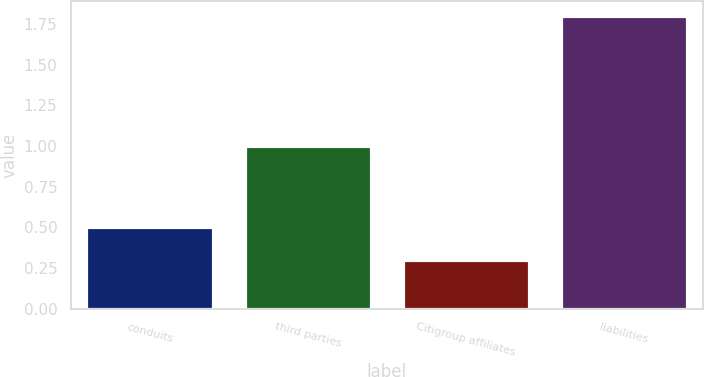Convert chart. <chart><loc_0><loc_0><loc_500><loc_500><bar_chart><fcel>conduits<fcel>third parties<fcel>Citigroup affiliates<fcel>liabilities<nl><fcel>0.5<fcel>1<fcel>0.3<fcel>1.8<nl></chart> 